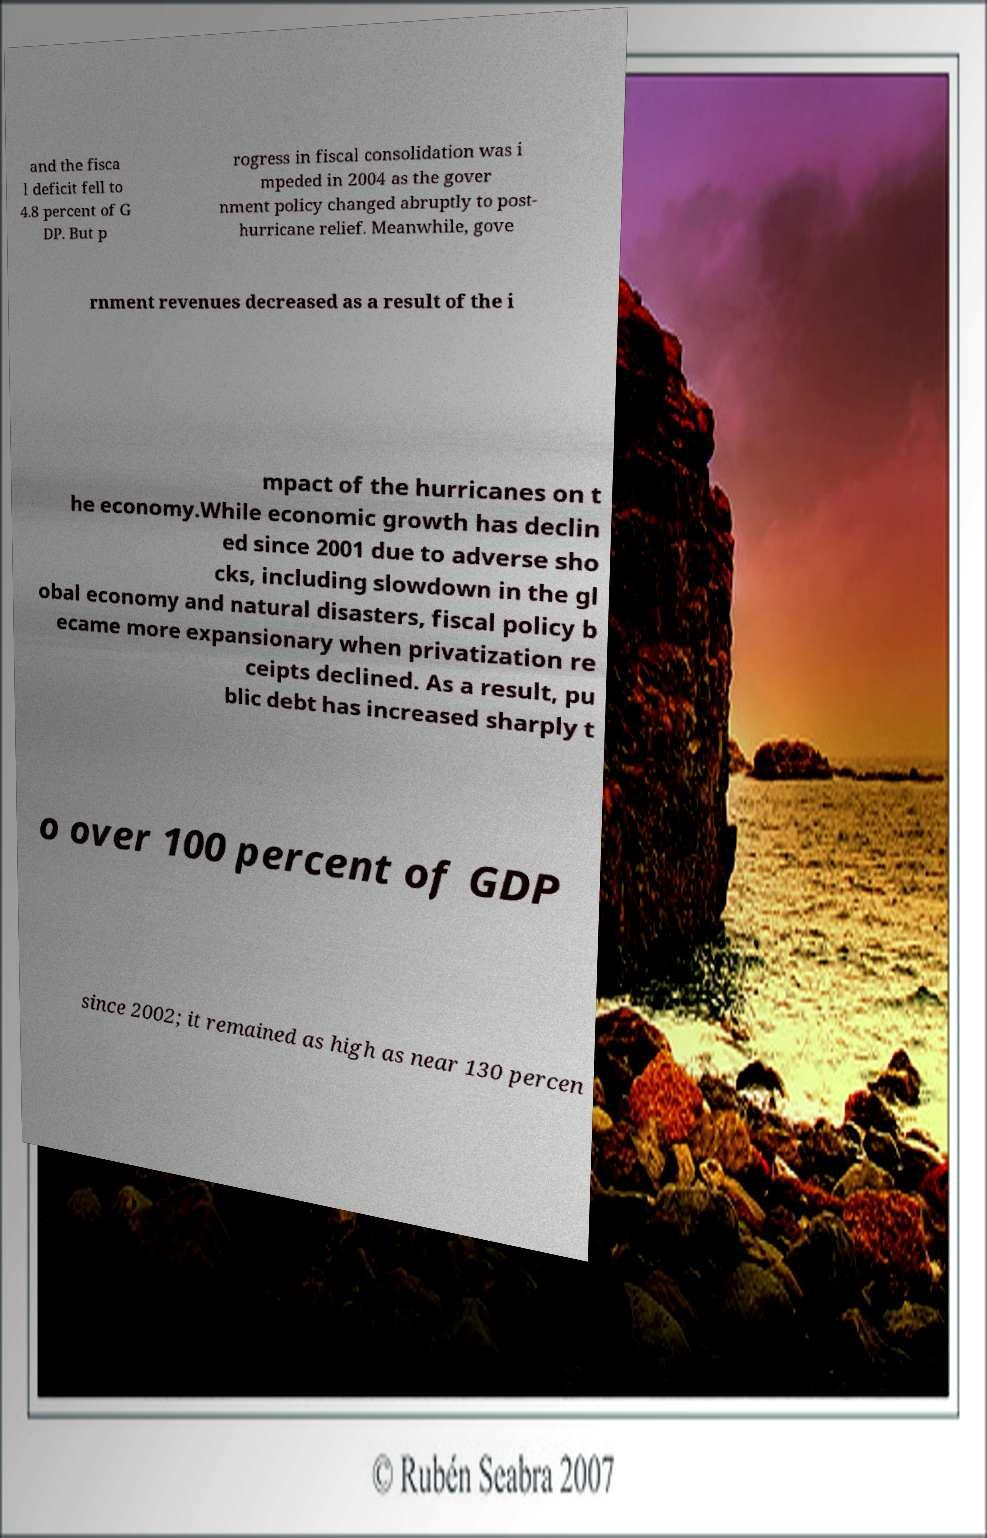Can you accurately transcribe the text from the provided image for me? and the fisca l deficit fell to 4.8 percent of G DP. But p rogress in fiscal consolidation was i mpeded in 2004 as the gover nment policy changed abruptly to post- hurricane relief. Meanwhile, gove rnment revenues decreased as a result of the i mpact of the hurricanes on t he economy.While economic growth has declin ed since 2001 due to adverse sho cks, including slowdown in the gl obal economy and natural disasters, fiscal policy b ecame more expansionary when privatization re ceipts declined. As a result, pu blic debt has increased sharply t o over 100 percent of GDP since 2002; it remained as high as near 130 percen 